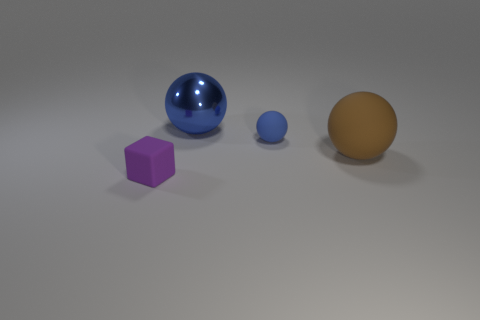Add 2 tiny purple matte cubes. How many objects exist? 6 Subtract all cubes. How many objects are left? 3 Add 1 big blue metallic objects. How many big blue metallic objects are left? 2 Add 3 large metal spheres. How many large metal spheres exist? 4 Subtract 0 red cubes. How many objects are left? 4 Subtract all large brown rubber balls. Subtract all big things. How many objects are left? 1 